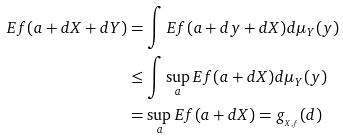Convert formula to latex. <formula><loc_0><loc_0><loc_500><loc_500>E f ( a + d X + d Y ) & = \int E f ( a + d y + d X ) d \mu _ { Y } ( y ) \\ & \leq \int \sup _ { a } E f ( a + d X ) d \mu _ { Y } ( y ) \\ & = \sup _ { a } E f ( a + d X ) = g _ { _ { X , f } } ( d )</formula> 